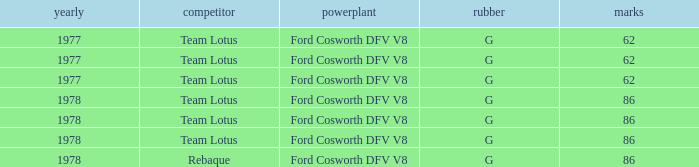Identify the motor with a focus size over 62 and features a participant from rebaque. Ford Cosworth DFV V8. 